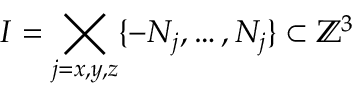Convert formula to latex. <formula><loc_0><loc_0><loc_500><loc_500>I = \Big t i m e s _ { j = x , y , z } \{ - N _ { j } , \dots , N _ { j } \} \subset { \mathbb { Z } } ^ { 3 }</formula> 